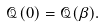Convert formula to latex. <formula><loc_0><loc_0><loc_500><loc_500>\mathcal { Q } ( 0 ) = \mathcal { Q } ( \beta ) .</formula> 